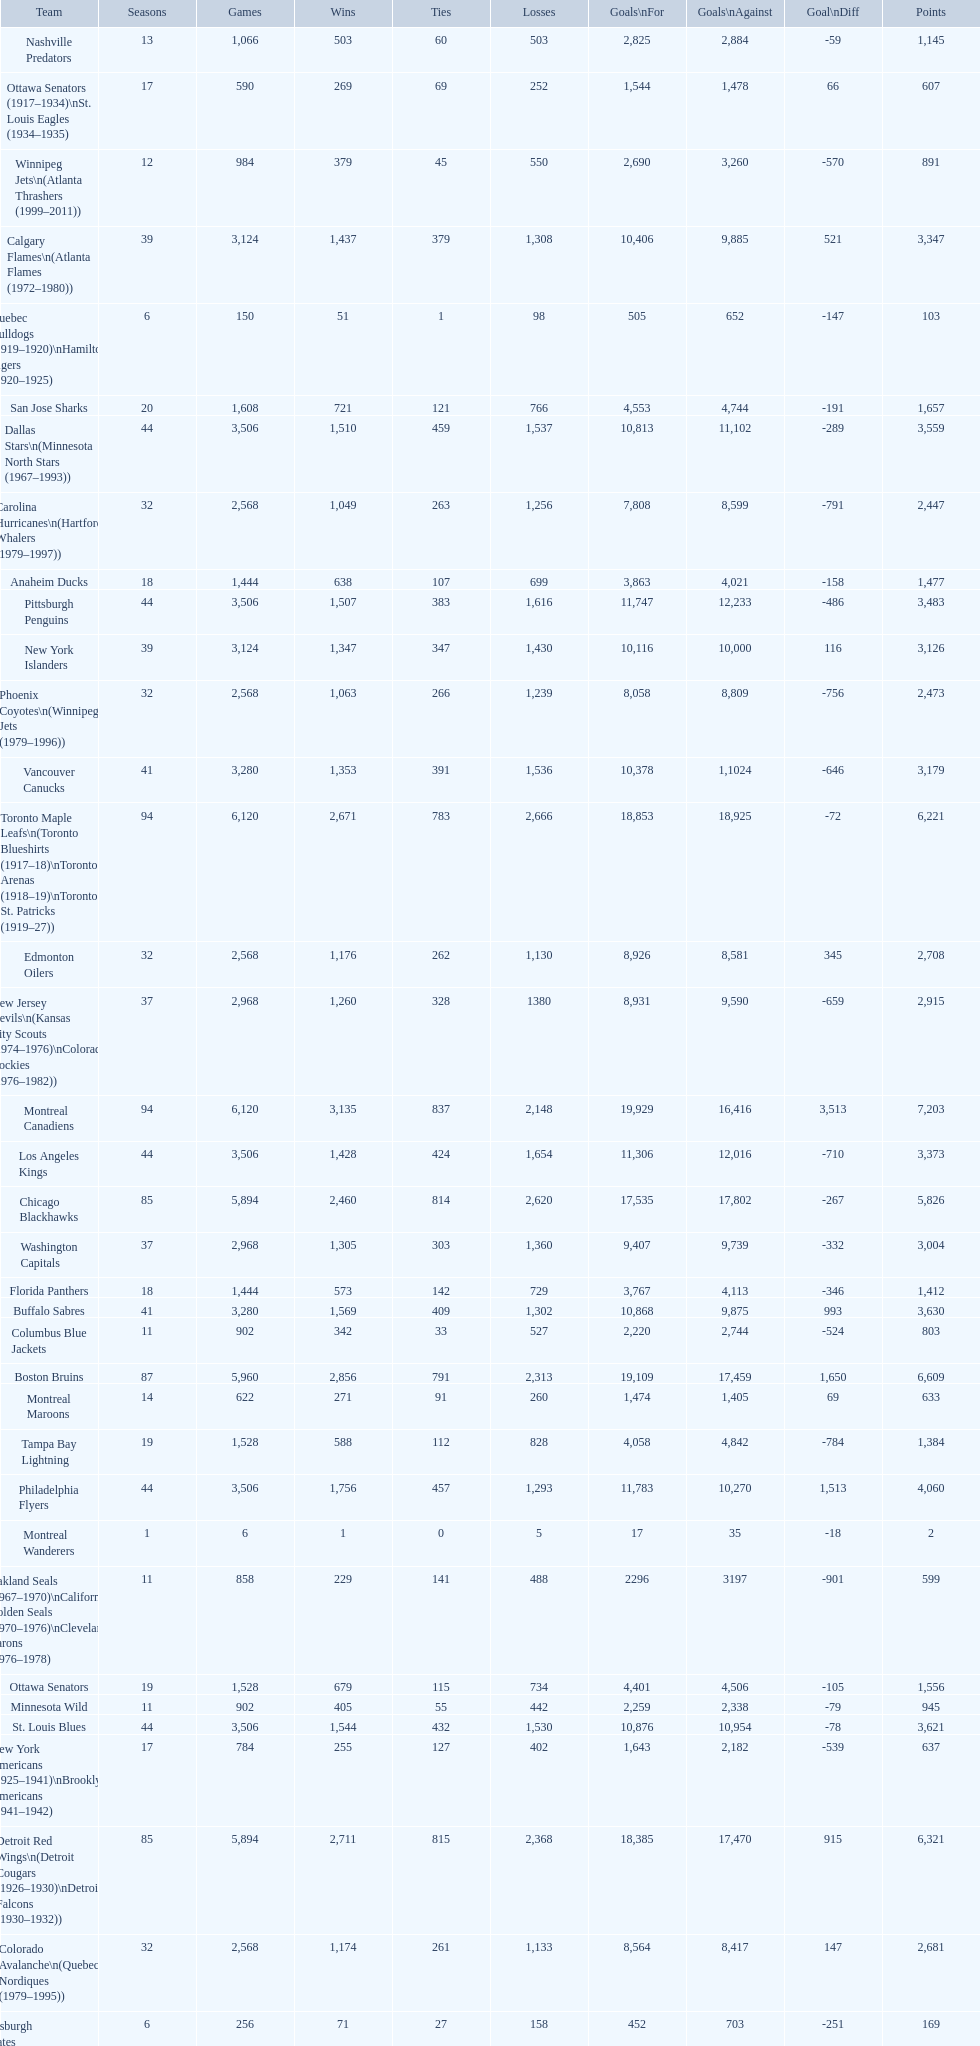What is the number of games that the vancouver canucks have won up to this point? 1,353. 